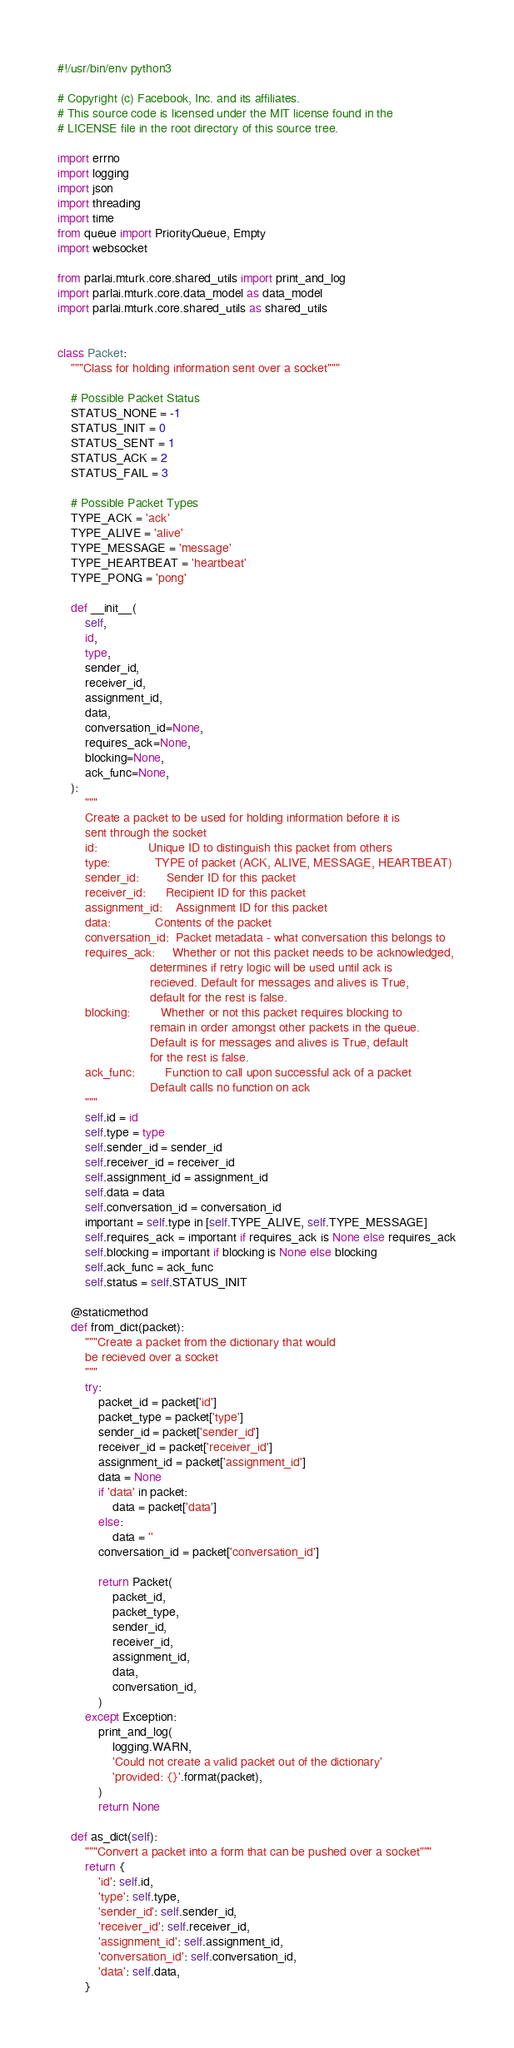Convert code to text. <code><loc_0><loc_0><loc_500><loc_500><_Python_>#!/usr/bin/env python3

# Copyright (c) Facebook, Inc. and its affiliates.
# This source code is licensed under the MIT license found in the
# LICENSE file in the root directory of this source tree.

import errno
import logging
import json
import threading
import time
from queue import PriorityQueue, Empty
import websocket

from parlai.mturk.core.shared_utils import print_and_log
import parlai.mturk.core.data_model as data_model
import parlai.mturk.core.shared_utils as shared_utils


class Packet:
    """Class for holding information sent over a socket"""

    # Possible Packet Status
    STATUS_NONE = -1
    STATUS_INIT = 0
    STATUS_SENT = 1
    STATUS_ACK = 2
    STATUS_FAIL = 3

    # Possible Packet Types
    TYPE_ACK = 'ack'
    TYPE_ALIVE = 'alive'
    TYPE_MESSAGE = 'message'
    TYPE_HEARTBEAT = 'heartbeat'
    TYPE_PONG = 'pong'

    def __init__(
        self,
        id,
        type,
        sender_id,
        receiver_id,
        assignment_id,
        data,
        conversation_id=None,
        requires_ack=None,
        blocking=None,
        ack_func=None,
    ):
        """
        Create a packet to be used for holding information before it is
        sent through the socket
        id:               Unique ID to distinguish this packet from others
        type:             TYPE of packet (ACK, ALIVE, MESSAGE, HEARTBEAT)
        sender_id:        Sender ID for this packet
        receiver_id:      Recipient ID for this packet
        assignment_id:    Assignment ID for this packet
        data:             Contents of the packet
        conversation_id:  Packet metadata - what conversation this belongs to
        requires_ack:     Whether or not this packet needs to be acknowledged,
                           determines if retry logic will be used until ack is
                           recieved. Default for messages and alives is True,
                           default for the rest is false.
        blocking:         Whether or not this packet requires blocking to
                           remain in order amongst other packets in the queue.
                           Default is for messages and alives is True, default
                           for the rest is false.
        ack_func:         Function to call upon successful ack of a packet
                           Default calls no function on ack
        """
        self.id = id
        self.type = type
        self.sender_id = sender_id
        self.receiver_id = receiver_id
        self.assignment_id = assignment_id
        self.data = data
        self.conversation_id = conversation_id
        important = self.type in [self.TYPE_ALIVE, self.TYPE_MESSAGE]
        self.requires_ack = important if requires_ack is None else requires_ack
        self.blocking = important if blocking is None else blocking
        self.ack_func = ack_func
        self.status = self.STATUS_INIT

    @staticmethod
    def from_dict(packet):
        """Create a packet from the dictionary that would
        be recieved over a socket
        """
        try:
            packet_id = packet['id']
            packet_type = packet['type']
            sender_id = packet['sender_id']
            receiver_id = packet['receiver_id']
            assignment_id = packet['assignment_id']
            data = None
            if 'data' in packet:
                data = packet['data']
            else:
                data = ''
            conversation_id = packet['conversation_id']

            return Packet(
                packet_id,
                packet_type,
                sender_id,
                receiver_id,
                assignment_id,
                data,
                conversation_id,
            )
        except Exception:
            print_and_log(
                logging.WARN,
                'Could not create a valid packet out of the dictionary'
                'provided: {}'.format(packet),
            )
            return None

    def as_dict(self):
        """Convert a packet into a form that can be pushed over a socket"""
        return {
            'id': self.id,
            'type': self.type,
            'sender_id': self.sender_id,
            'receiver_id': self.receiver_id,
            'assignment_id': self.assignment_id,
            'conversation_id': self.conversation_id,
            'data': self.data,
        }
</code> 